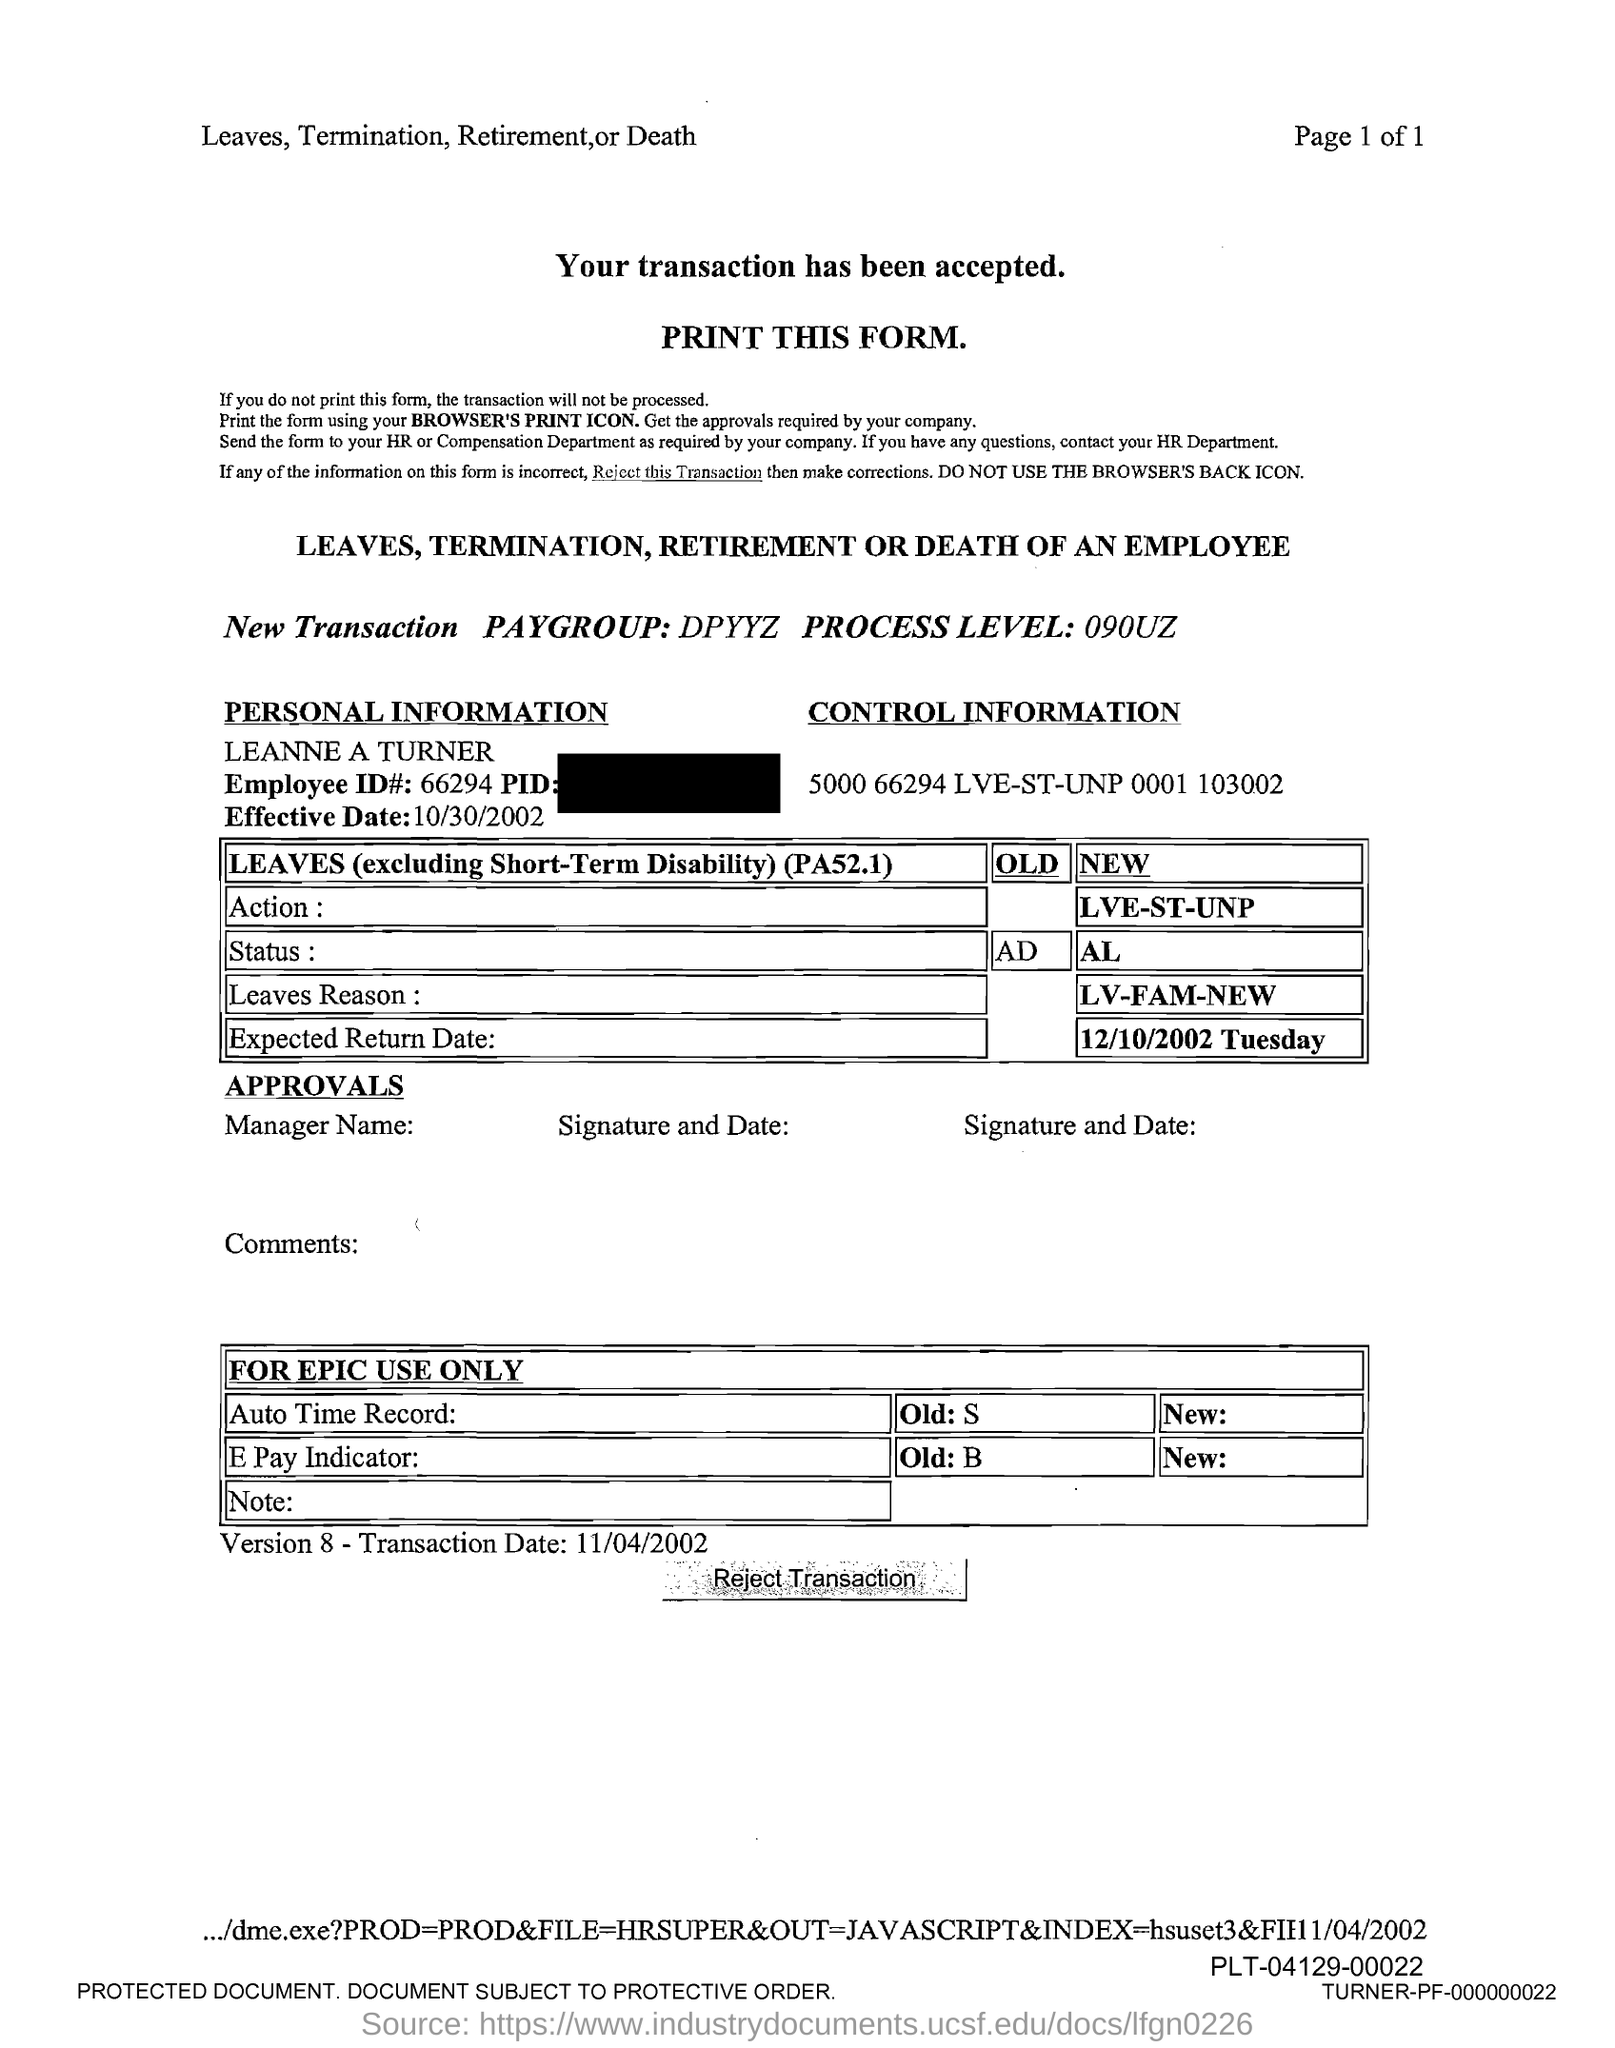What is the Employee id#?
Provide a short and direct response. 66294. 